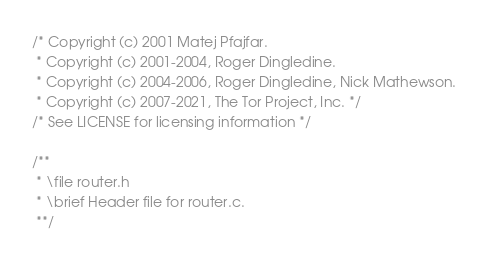Convert code to text. <code><loc_0><loc_0><loc_500><loc_500><_C_>/* Copyright (c) 2001 Matej Pfajfar.
 * Copyright (c) 2001-2004, Roger Dingledine.
 * Copyright (c) 2004-2006, Roger Dingledine, Nick Mathewson.
 * Copyright (c) 2007-2021, The Tor Project, Inc. */
/* See LICENSE for licensing information */

/**
 * \file router.h
 * \brief Header file for router.c.
 **/
</code> 